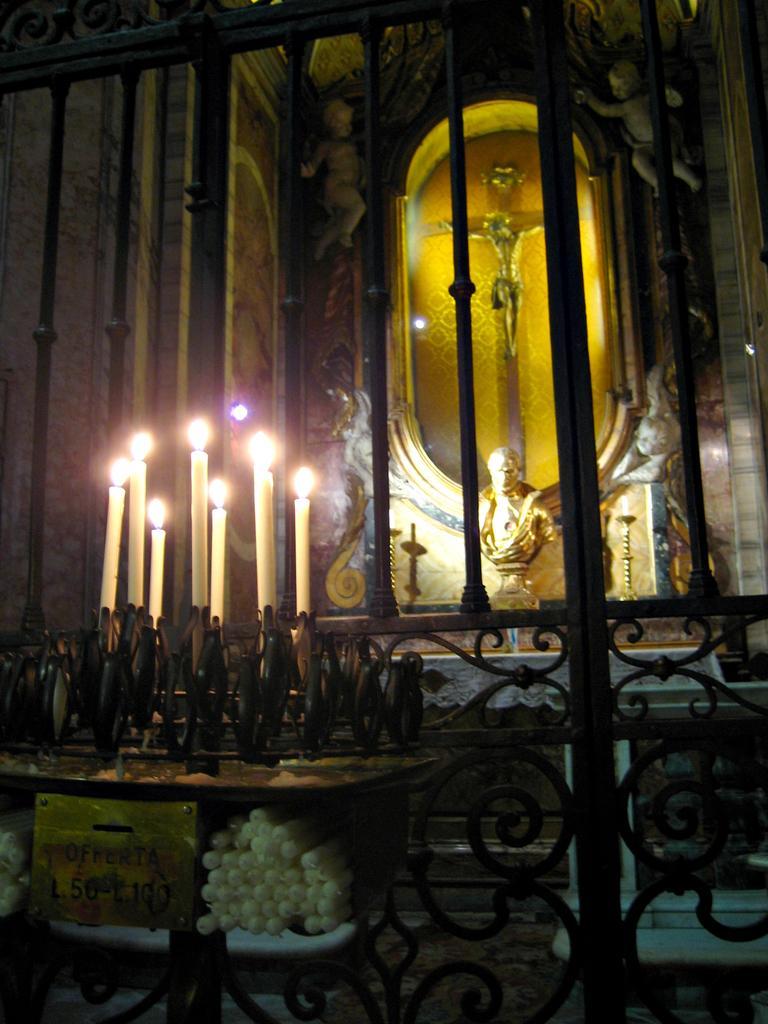Could you give a brief overview of what you see in this image? In this image we can few candles which are placed in front of the statues and in the back ground, we can see the statue of a Jesus Christ on a cross. 